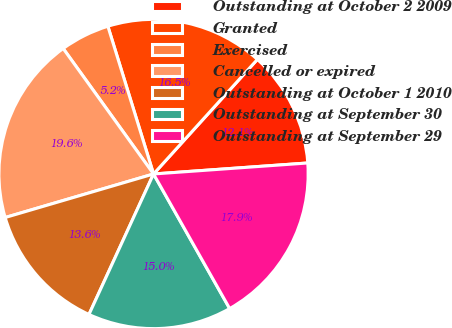Convert chart. <chart><loc_0><loc_0><loc_500><loc_500><pie_chart><fcel>Outstanding at October 2 2009<fcel>Granted<fcel>Exercised<fcel>Cancelled or expired<fcel>Outstanding at October 1 2010<fcel>Outstanding at September 30<fcel>Outstanding at September 29<nl><fcel>12.15%<fcel>16.49%<fcel>5.16%<fcel>19.61%<fcel>13.6%<fcel>15.05%<fcel>17.94%<nl></chart> 